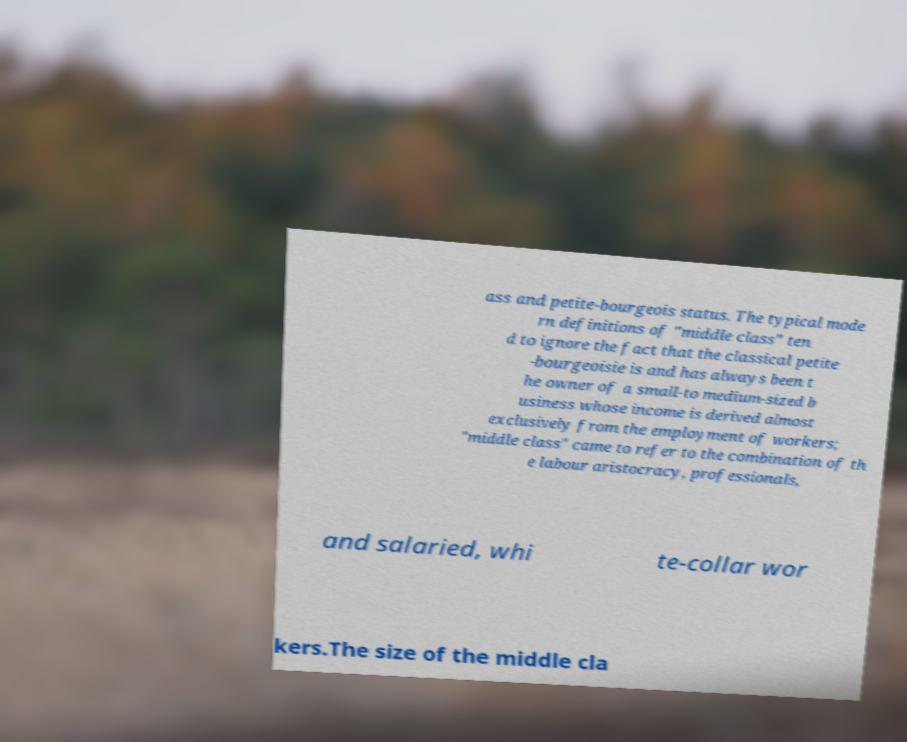Could you extract and type out the text from this image? ass and petite-bourgeois status. The typical mode rn definitions of "middle class" ten d to ignore the fact that the classical petite -bourgeoisie is and has always been t he owner of a small-to medium-sized b usiness whose income is derived almost exclusively from the employment of workers; "middle class" came to refer to the combination of th e labour aristocracy, professionals, and salaried, whi te-collar wor kers.The size of the middle cla 